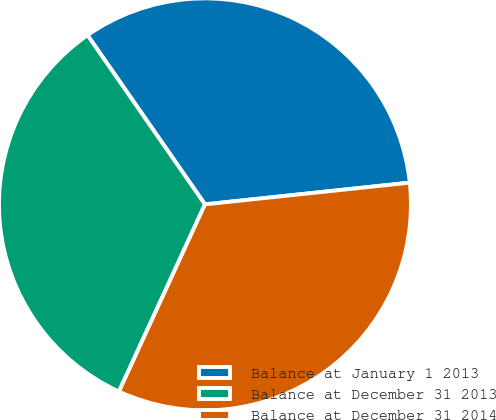Convert chart. <chart><loc_0><loc_0><loc_500><loc_500><pie_chart><fcel>Balance at January 1 2013<fcel>Balance at December 31 2013<fcel>Balance at December 31 2014<nl><fcel>32.98%<fcel>33.49%<fcel>33.54%<nl></chart> 